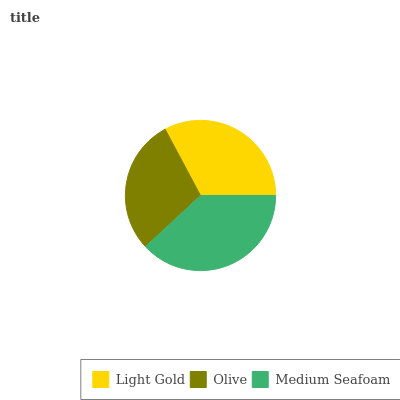Is Olive the minimum?
Answer yes or no. Yes. Is Medium Seafoam the maximum?
Answer yes or no. Yes. Is Medium Seafoam the minimum?
Answer yes or no. No. Is Olive the maximum?
Answer yes or no. No. Is Medium Seafoam greater than Olive?
Answer yes or no. Yes. Is Olive less than Medium Seafoam?
Answer yes or no. Yes. Is Olive greater than Medium Seafoam?
Answer yes or no. No. Is Medium Seafoam less than Olive?
Answer yes or no. No. Is Light Gold the high median?
Answer yes or no. Yes. Is Light Gold the low median?
Answer yes or no. Yes. Is Medium Seafoam the high median?
Answer yes or no. No. Is Olive the low median?
Answer yes or no. No. 